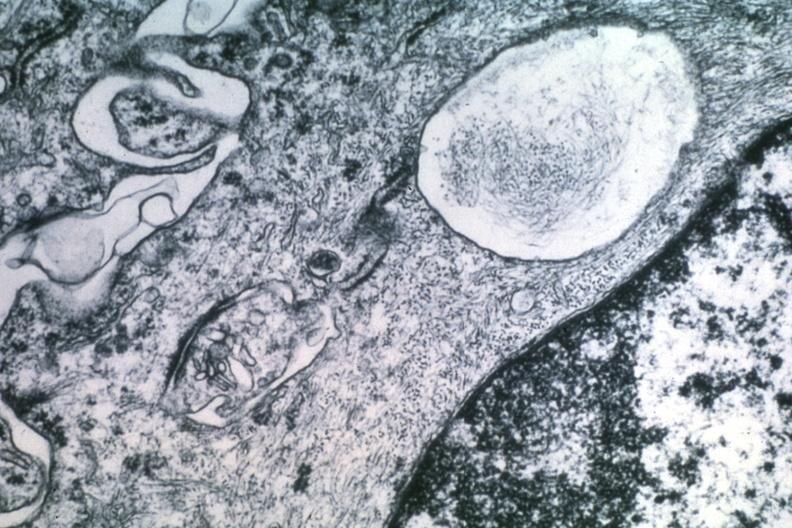s mucinous cystadenocarcinoma present?
Answer the question using a single word or phrase. No 